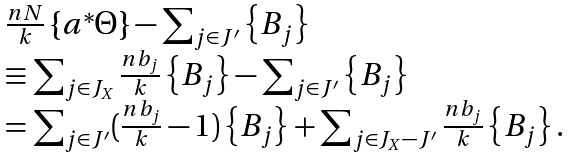<formula> <loc_0><loc_0><loc_500><loc_500>\begin{array} { l } \frac { n N } { k } \left \{ a ^ { * } \Theta \right \} - \sum \nolimits _ { j \in J ^ { \prime } } \left \{ B _ { j } \right \} \\ \equiv \sum \nolimits _ { j \in J _ { X } } \frac { n b _ { j } } { k } \left \{ B _ { j } \right \} - \sum \nolimits _ { j \in J ^ { \prime } } \left \{ B _ { j } \right \} \\ = \sum \nolimits _ { j \in J ^ { \prime } } ( \frac { n b _ { j } } { k } - 1 ) \left \{ B _ { j } \right \} + \sum \nolimits _ { j \in J _ { X } - J ^ { \prime } } \frac { n b _ { j } } { k } \left \{ B _ { j } \right \} . \end{array}</formula> 